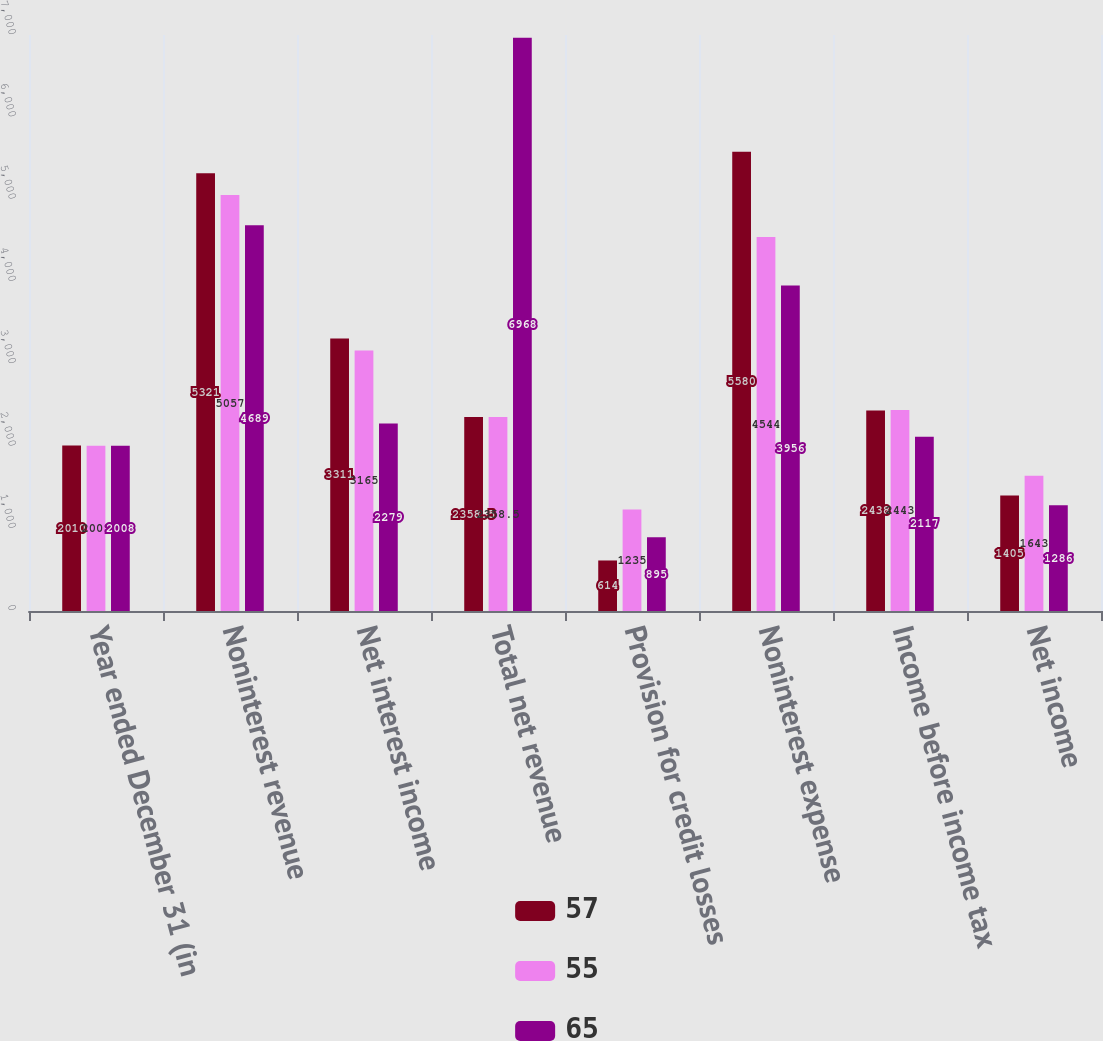Convert chart to OTSL. <chart><loc_0><loc_0><loc_500><loc_500><stacked_bar_chart><ecel><fcel>Year ended December 31 (in<fcel>Noninterest revenue<fcel>Net interest income<fcel>Total net revenue<fcel>Provision for credit losses<fcel>Noninterest expense<fcel>Income before income tax<fcel>Net income<nl><fcel>57<fcel>2010<fcel>5321<fcel>3311<fcel>2358.5<fcel>614<fcel>5580<fcel>2438<fcel>1405<nl><fcel>55<fcel>2009<fcel>5057<fcel>3165<fcel>2358.5<fcel>1235<fcel>4544<fcel>2443<fcel>1643<nl><fcel>65<fcel>2008<fcel>4689<fcel>2279<fcel>6968<fcel>895<fcel>3956<fcel>2117<fcel>1286<nl></chart> 